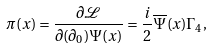<formula> <loc_0><loc_0><loc_500><loc_500>\pi ( x ) = \frac { \partial \mathcal { L } } { \partial ( \partial _ { 0 } ) \Psi ( x ) } = \frac { i } { 2 } \overline { \Psi } ( x ) \Gamma _ { 4 } ,</formula> 